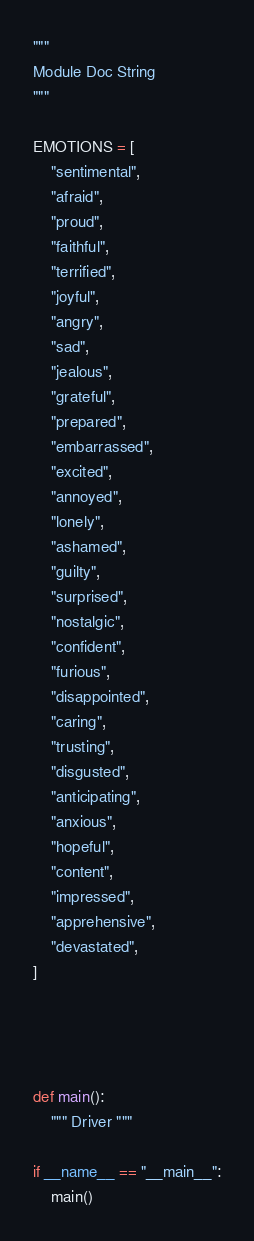Convert code to text. <code><loc_0><loc_0><loc_500><loc_500><_Python_>"""
Module Doc String
"""

EMOTIONS = [
    "sentimental",
    "afraid",
    "proud",
    "faithful",
    "terrified",
    "joyful",
    "angry",
    "sad",
    "jealous",
    "grateful",
    "prepared",
    "embarrassed",
    "excited",
    "annoyed",
    "lonely",
    "ashamed",
    "guilty",
    "surprised",
    "nostalgic",
    "confident",
    "furious",
    "disappointed",
    "caring",
    "trusting",
    "disgusted",
    "anticipating",
    "anxious",
    "hopeful",
    "content",
    "impressed",
    "apprehensive",
    "devastated",
]




def main():
    """ Driver """

if __name__ == "__main__":
    main()

</code> 